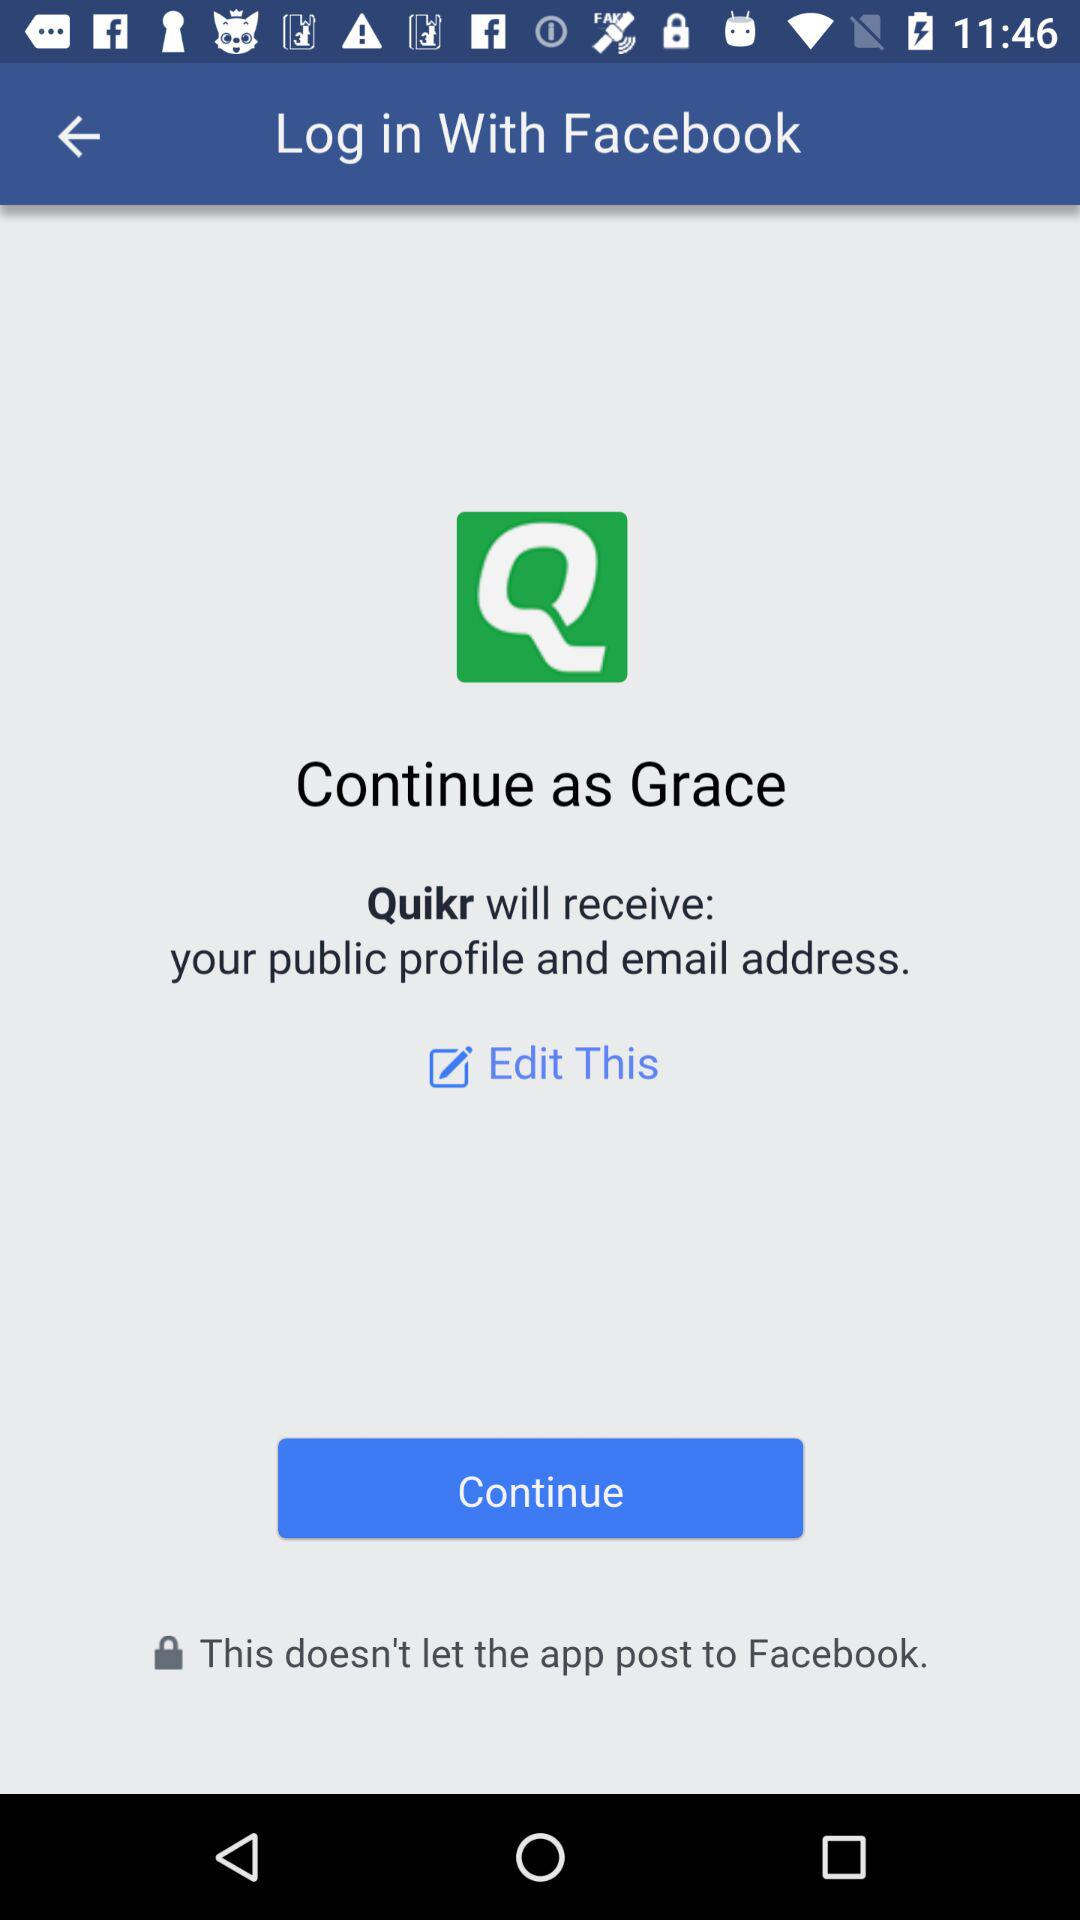What is the application name? The application name is "Quikr". 